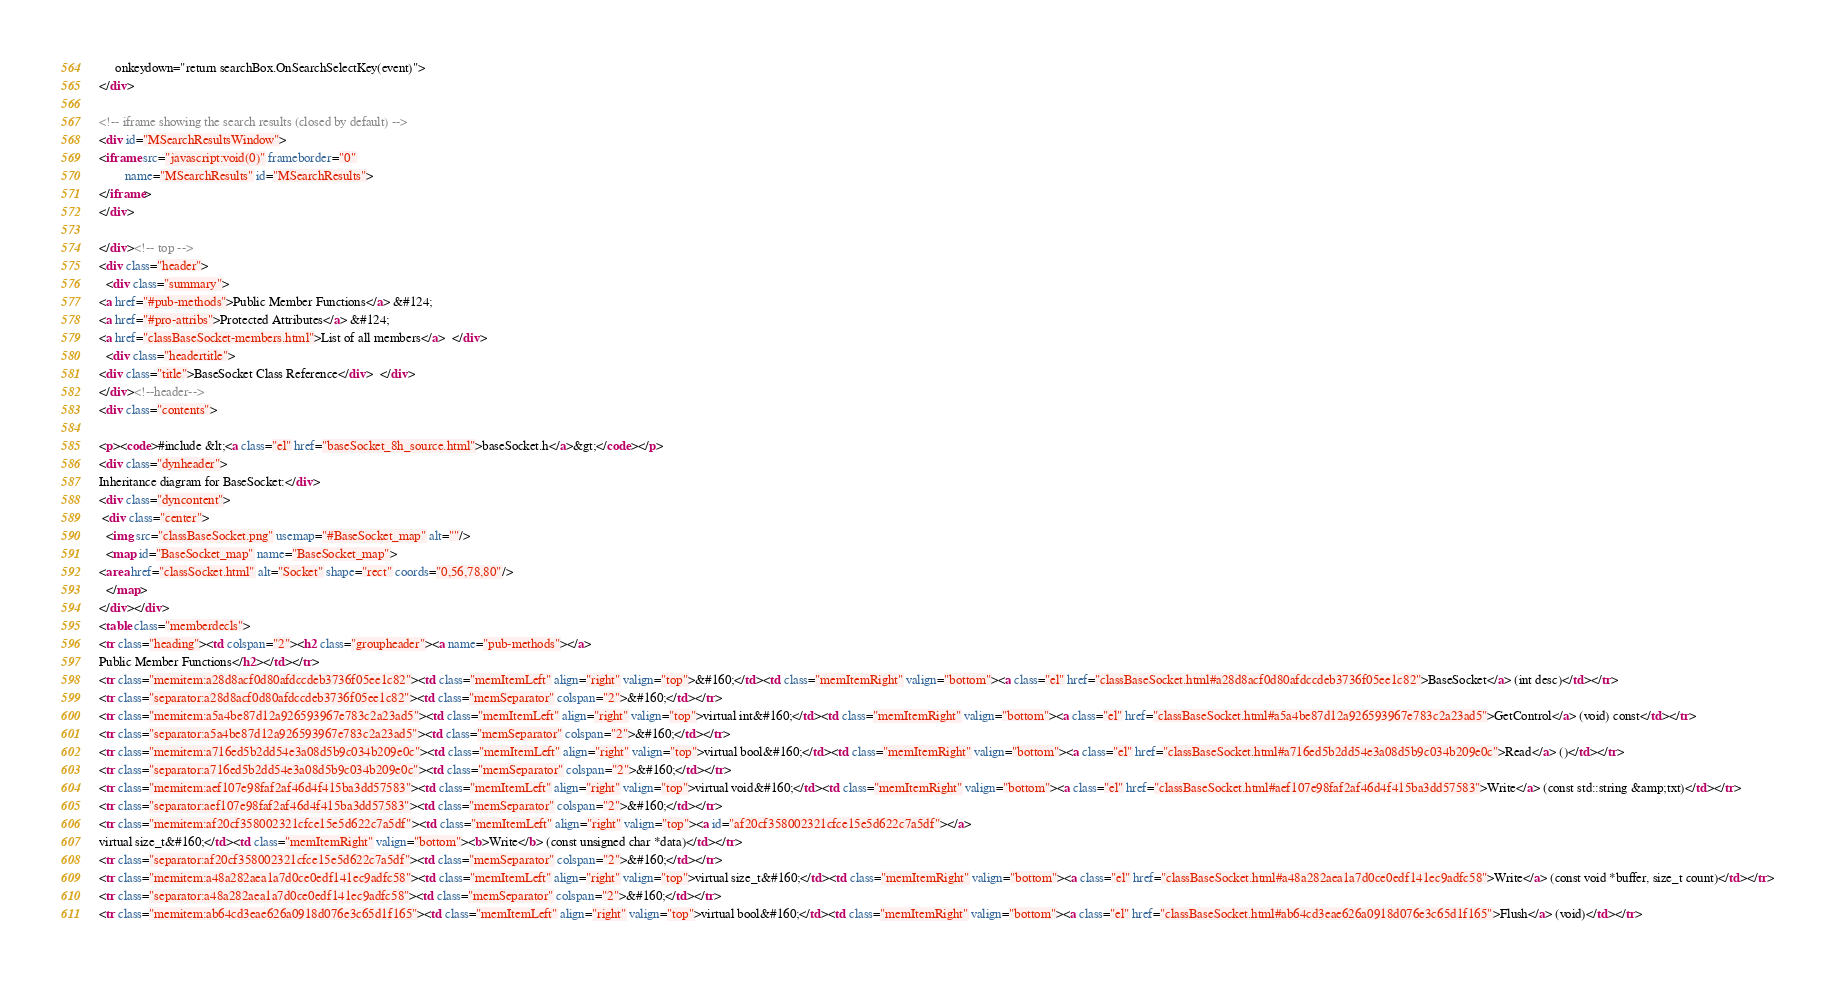<code> <loc_0><loc_0><loc_500><loc_500><_HTML_>     onkeydown="return searchBox.OnSearchSelectKey(event)">
</div>

<!-- iframe showing the search results (closed by default) -->
<div id="MSearchResultsWindow">
<iframe src="javascript:void(0)" frameborder="0" 
        name="MSearchResults" id="MSearchResults">
</iframe>
</div>

</div><!-- top -->
<div class="header">
  <div class="summary">
<a href="#pub-methods">Public Member Functions</a> &#124;
<a href="#pro-attribs">Protected Attributes</a> &#124;
<a href="classBaseSocket-members.html">List of all members</a>  </div>
  <div class="headertitle">
<div class="title">BaseSocket Class Reference</div>  </div>
</div><!--header-->
<div class="contents">

<p><code>#include &lt;<a class="el" href="baseSocket_8h_source.html">baseSocket.h</a>&gt;</code></p>
<div class="dynheader">
Inheritance diagram for BaseSocket:</div>
<div class="dyncontent">
 <div class="center">
  <img src="classBaseSocket.png" usemap="#BaseSocket_map" alt=""/>
  <map id="BaseSocket_map" name="BaseSocket_map">
<area href="classSocket.html" alt="Socket" shape="rect" coords="0,56,78,80"/>
  </map>
</div></div>
<table class="memberdecls">
<tr class="heading"><td colspan="2"><h2 class="groupheader"><a name="pub-methods"></a>
Public Member Functions</h2></td></tr>
<tr class="memitem:a28d8acf0d80afdccdeb3736f05ee1c82"><td class="memItemLeft" align="right" valign="top">&#160;</td><td class="memItemRight" valign="bottom"><a class="el" href="classBaseSocket.html#a28d8acf0d80afdccdeb3736f05ee1c82">BaseSocket</a> (int desc)</td></tr>
<tr class="separator:a28d8acf0d80afdccdeb3736f05ee1c82"><td class="memSeparator" colspan="2">&#160;</td></tr>
<tr class="memitem:a5a4be87d12a926593967e783c2a23ad5"><td class="memItemLeft" align="right" valign="top">virtual int&#160;</td><td class="memItemRight" valign="bottom"><a class="el" href="classBaseSocket.html#a5a4be87d12a926593967e783c2a23ad5">GetControl</a> (void) const</td></tr>
<tr class="separator:a5a4be87d12a926593967e783c2a23ad5"><td class="memSeparator" colspan="2">&#160;</td></tr>
<tr class="memitem:a716ed5b2dd54e3a08d5b9c034b209e0c"><td class="memItemLeft" align="right" valign="top">virtual bool&#160;</td><td class="memItemRight" valign="bottom"><a class="el" href="classBaseSocket.html#a716ed5b2dd54e3a08d5b9c034b209e0c">Read</a> ()</td></tr>
<tr class="separator:a716ed5b2dd54e3a08d5b9c034b209e0c"><td class="memSeparator" colspan="2">&#160;</td></tr>
<tr class="memitem:aef107e98faf2af46d4f415ba3dd57583"><td class="memItemLeft" align="right" valign="top">virtual void&#160;</td><td class="memItemRight" valign="bottom"><a class="el" href="classBaseSocket.html#aef107e98faf2af46d4f415ba3dd57583">Write</a> (const std::string &amp;txt)</td></tr>
<tr class="separator:aef107e98faf2af46d4f415ba3dd57583"><td class="memSeparator" colspan="2">&#160;</td></tr>
<tr class="memitem:af20cf358002321cfce15e5d622c7a5df"><td class="memItemLeft" align="right" valign="top"><a id="af20cf358002321cfce15e5d622c7a5df"></a>
virtual size_t&#160;</td><td class="memItemRight" valign="bottom"><b>Write</b> (const unsigned char *data)</td></tr>
<tr class="separator:af20cf358002321cfce15e5d622c7a5df"><td class="memSeparator" colspan="2">&#160;</td></tr>
<tr class="memitem:a48a282aea1a7d0ce0edf141ec9adfc58"><td class="memItemLeft" align="right" valign="top">virtual size_t&#160;</td><td class="memItemRight" valign="bottom"><a class="el" href="classBaseSocket.html#a48a282aea1a7d0ce0edf141ec9adfc58">Write</a> (const void *buffer, size_t count)</td></tr>
<tr class="separator:a48a282aea1a7d0ce0edf141ec9adfc58"><td class="memSeparator" colspan="2">&#160;</td></tr>
<tr class="memitem:ab64cd3eae626a0918d076e3c65d1f165"><td class="memItemLeft" align="right" valign="top">virtual bool&#160;</td><td class="memItemRight" valign="bottom"><a class="el" href="classBaseSocket.html#ab64cd3eae626a0918d076e3c65d1f165">Flush</a> (void)</td></tr></code> 